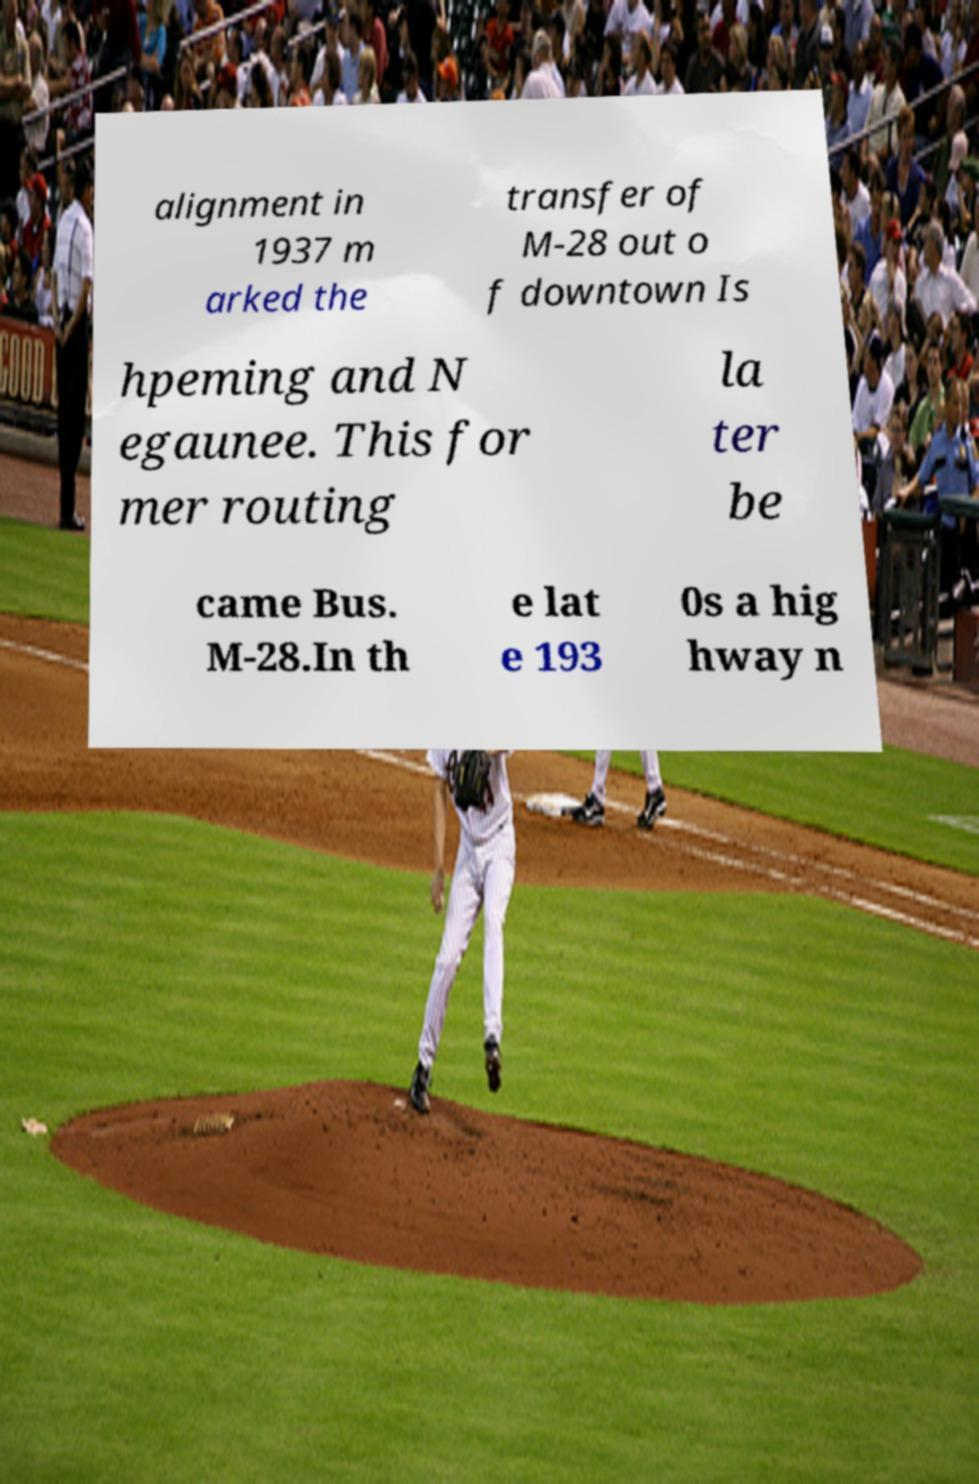For documentation purposes, I need the text within this image transcribed. Could you provide that? alignment in 1937 m arked the transfer of M-28 out o f downtown Is hpeming and N egaunee. This for mer routing la ter be came Bus. M-28.In th e lat e 193 0s a hig hway n 